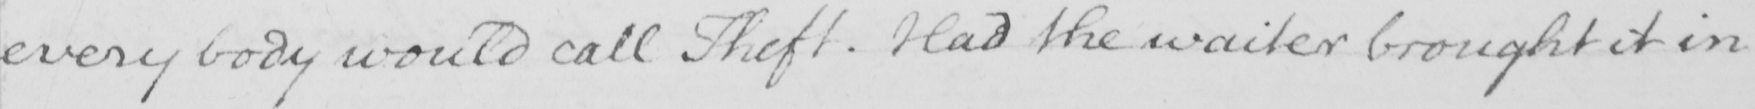What is written in this line of handwriting? every body would call Theft . Had the waiter brought it in 